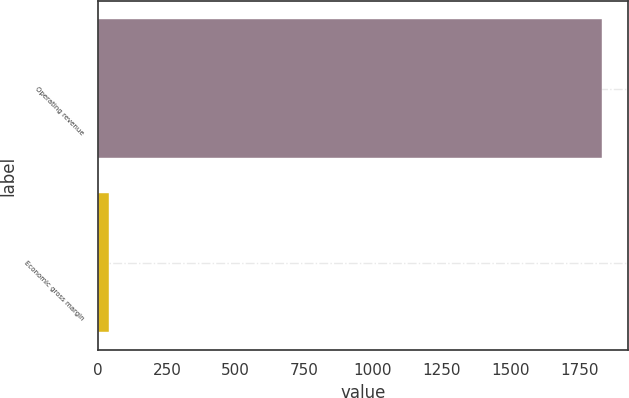<chart> <loc_0><loc_0><loc_500><loc_500><bar_chart><fcel>Operating revenue<fcel>Economic gross margin<nl><fcel>1834<fcel>38<nl></chart> 